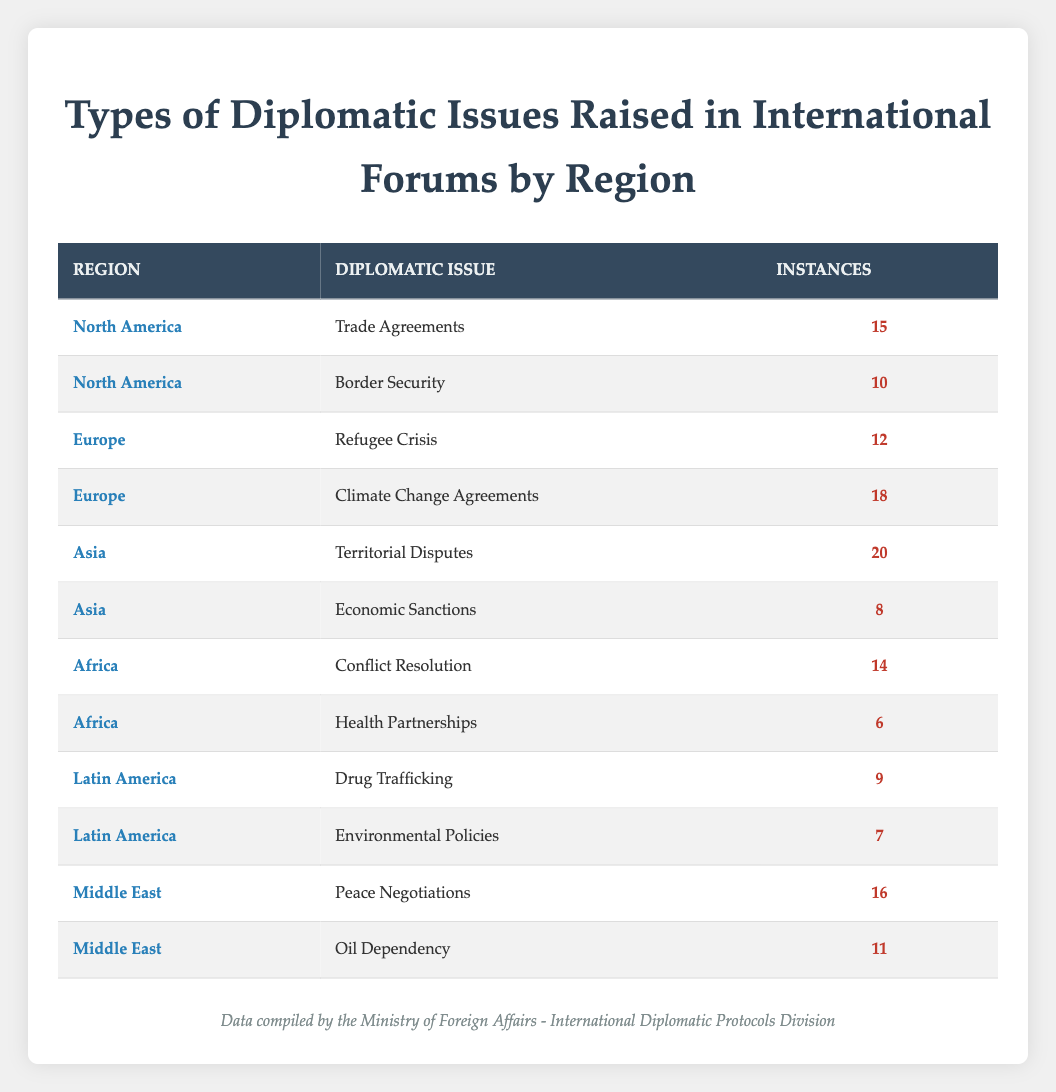What is the highest number of instances for a diplomatic issue in North America? The highest number of instances for a diplomatic issue in North America is for "Trade Agreements," which has 15 instances, while "Border Security" has 10 instances.
Answer: 15 Which region raised the most instances of diplomatic issues in total? To find the region with the highest total instances, we sum the instances for each region: North America (15 + 10 = 25), Europe (12 + 18 = 30), Asia (20 + 8 = 28), Africa (14 + 6 = 20), Latin America (9 + 7 = 16), and Middle East (16 + 11 = 27). The highest is Europe with a total of 30 instances.
Answer: 30 Is there a diplomatic issue related to health partnerships in Africa? Yes, the diplomatic issue "Health Partnerships" is present in Africa with 6 instances.
Answer: Yes How many instances are related to peace negotiations in the Middle East compared to trade agreements in North America? "Peace Negotiations" has 16 instances in the Middle East while "Trade Agreements" has 15 instances in North America. Therefore, the Middle East has 1 more instance than North America for these issues.
Answer: 1 more What is the average number of instances per diplomatic issue for Europe? In Europe, there are 2 diplomatic issues, Refugee Crisis (12 instances) and Climate Change Agreements (18 instances). The total instances are 12 + 18 = 30. To find the average, we divide by the number of issues: 30 / 2 = 15.
Answer: 15 Which region has the least instances for a single diplomatic issue? The lowest instances for a single diplomatic issue are 6, which corresponds to "Health Partnerships" in Africa.
Answer: 6 What percentage of diplomatic issues in Asia pertain to territorial disputes? There are 20 instances for "Territorial Disputes" and 8 for "Economic Sanctions" in Asia, summing up to 28 instances in total. The percentage for "Territorial Disputes" is (20 / 28) * 100 = approximately 71.43%.
Answer: Approximately 71.43% Are economic sanctions a prevalent diplomatic issue in Europe? No, economic sanctions are not listed as a diplomatic issue in Europe; it is mentioned for Asia instead.
Answer: No How many more instances are there for climate change agreements in Europe than drug trafficking in Latin America? "Climate Change Agreements" in Europe have 18 instances while "Drug Trafficking" in Latin America has 9 instances. The difference is 18 - 9 = 9 instances more for climate change agreements.
Answer: 9 instances more 